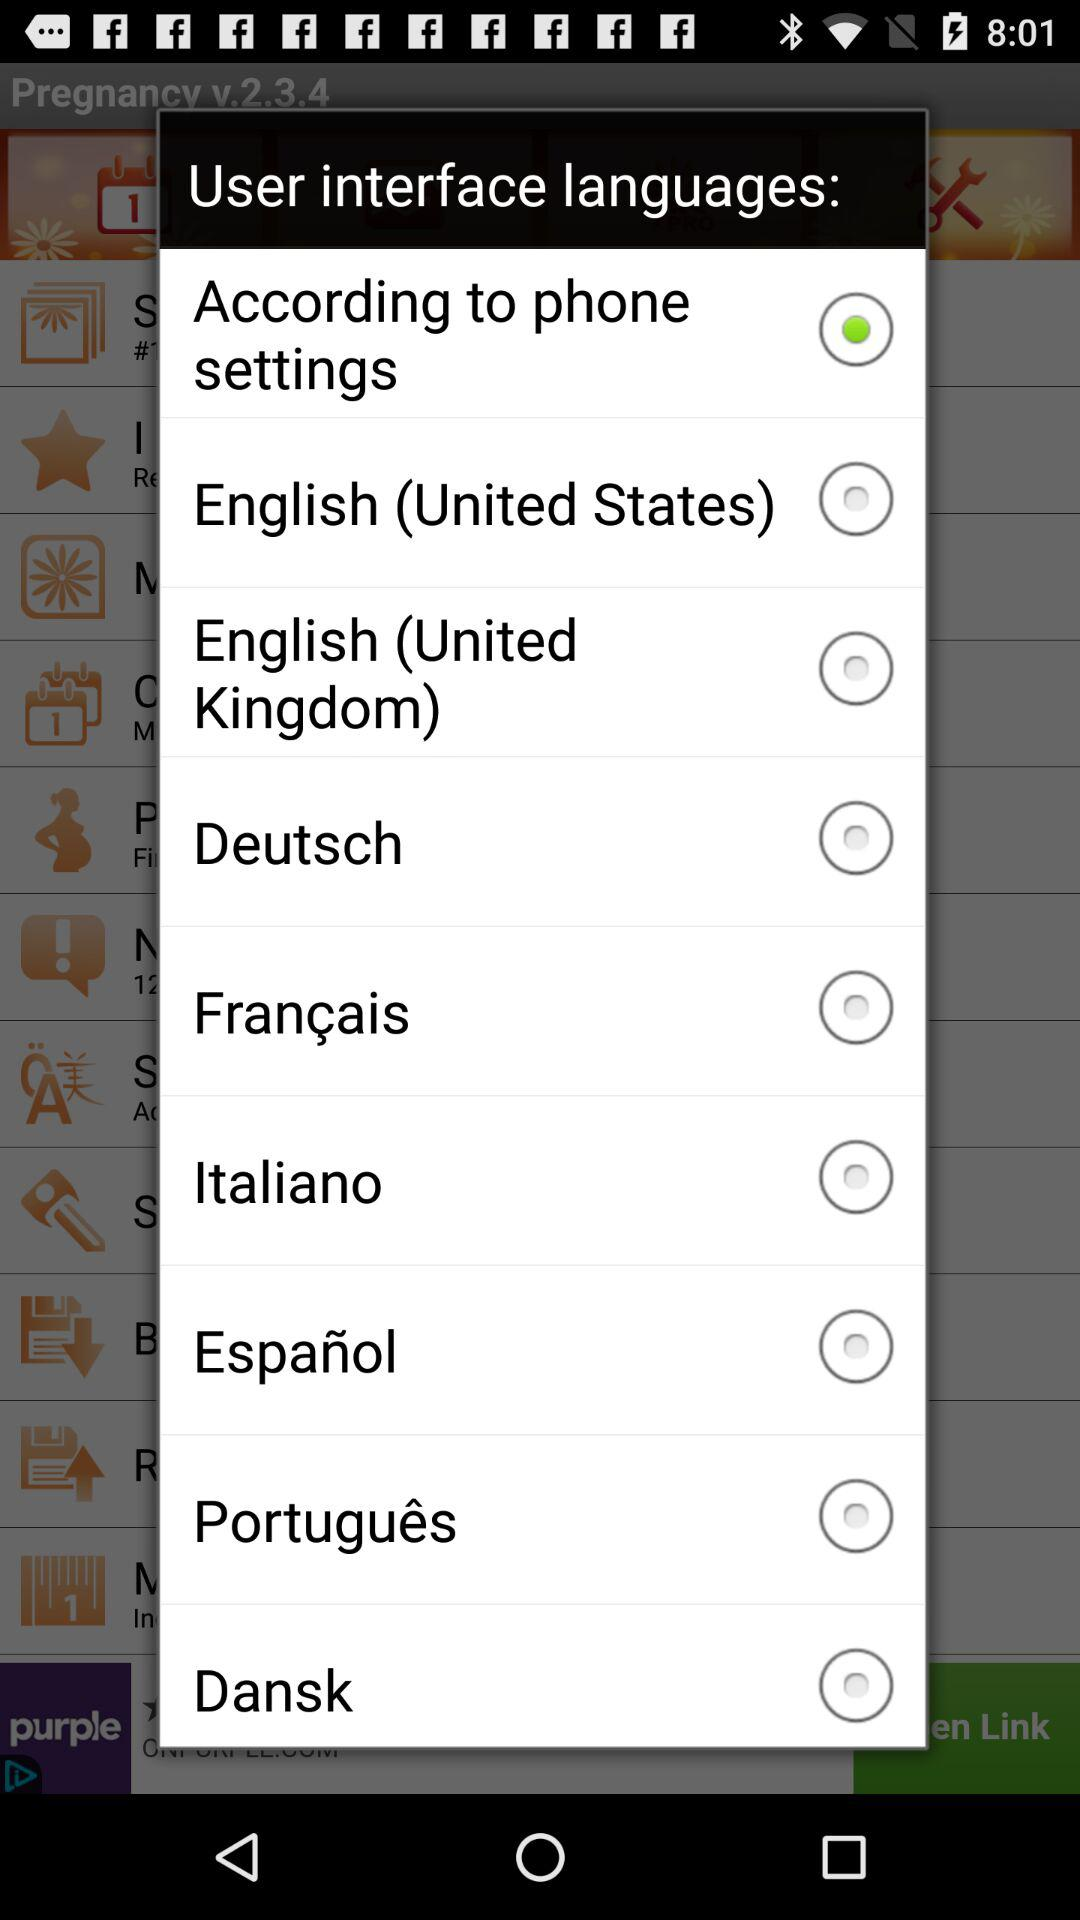Which option is selected? The selected option is "According to phone settings". 